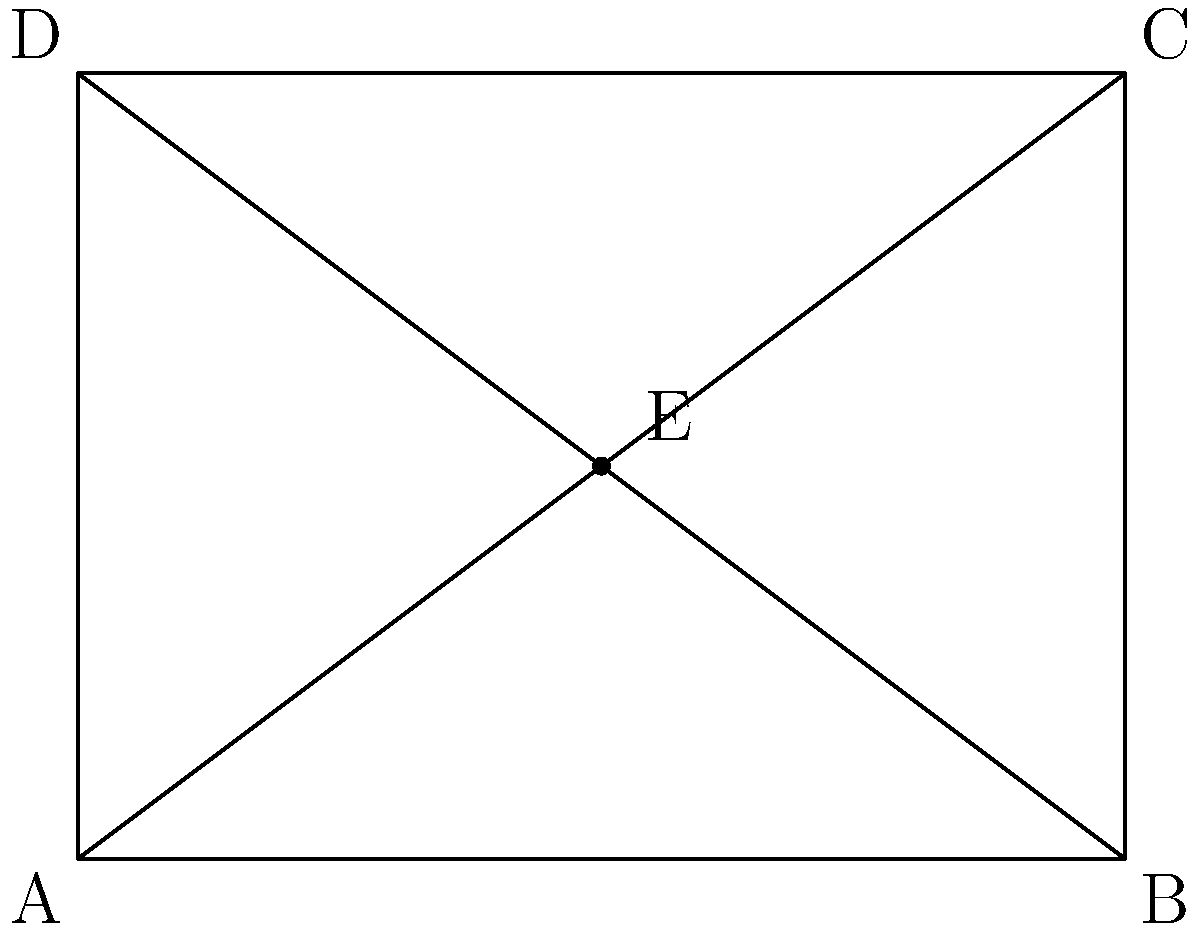In the school layout diagram, rectangle ABCD represents the entire school area. The diagonals AC and BD intersect at point E, which represents the central courtyard. If AE = EC and BE = ED, prove that triangles AEB and CED are congruent. How might this relate to balancing different peer groups within the school? Let's prove the congruence of triangles AEB and CED step-by-step:

1) Given: AE = EC and BE = ED

2) In rectangle ABCD:
   - AC and BD are diagonals
   - Diagonals of a rectangle bisect each other
   - Therefore, AE = EC and BE = ED (which confirms our given information)

3) ∠AEB and ∠CED are vertical angles, so ∠AEB = ∠CED

4) In rectangle ABCD, all angles are 90°
   So, ∠BAD = ∠BCD = 90°

5) ∠BAE = ∠DCE (alternate angles, as AC is a transversal for parallel lines AB and DC)

6) Now we have:
   - AE = EC (given)
   - ∠AEB = ∠CED (vertical angles)
   - ∠BAE = ∠DCE (alternate angles)

7) By the AAS (Angle-Angle-Side) congruence criterion, triangles AEB and CED are congruent.

Relating to peer groups:
This congruence could represent the importance of maintaining balance among different peer groups within the school. Just as the triangles are congruent and symmetrical around the central point E (courtyard), different social groups should have equal opportunities and representation within the school community. The central courtyard (E) could symbolize a common area where all groups interact and mix, promoting inclusivity and diversity.
Answer: Triangles AEB and CED are congruent by AAS criterion. 